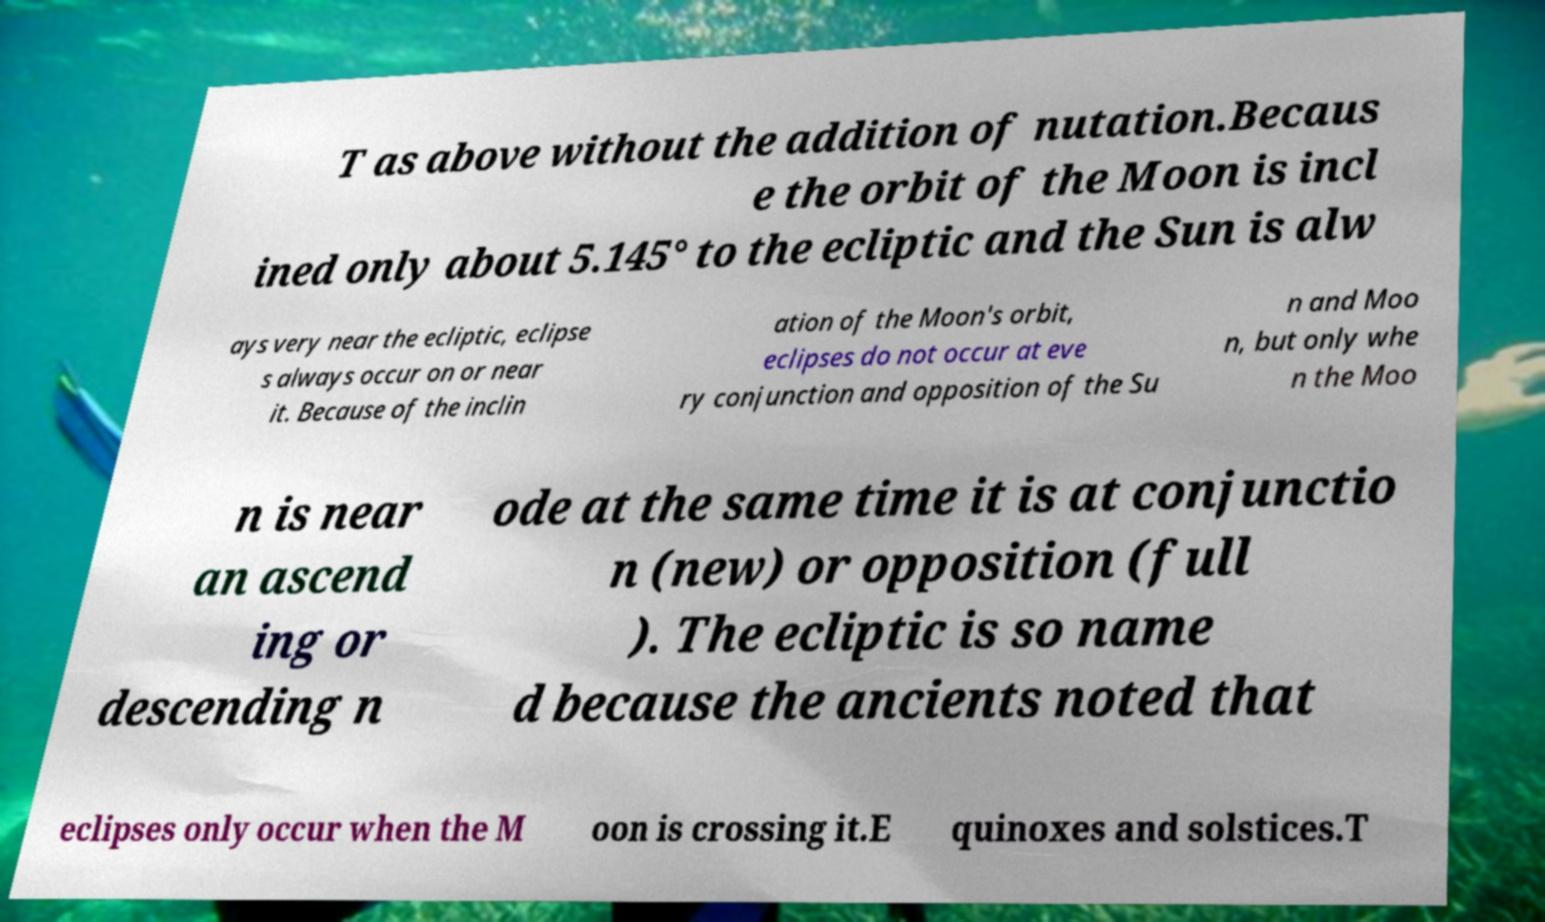Can you read and provide the text displayed in the image?This photo seems to have some interesting text. Can you extract and type it out for me? T as above without the addition of nutation.Becaus e the orbit of the Moon is incl ined only about 5.145° to the ecliptic and the Sun is alw ays very near the ecliptic, eclipse s always occur on or near it. Because of the inclin ation of the Moon's orbit, eclipses do not occur at eve ry conjunction and opposition of the Su n and Moo n, but only whe n the Moo n is near an ascend ing or descending n ode at the same time it is at conjunctio n (new) or opposition (full ). The ecliptic is so name d because the ancients noted that eclipses only occur when the M oon is crossing it.E quinoxes and solstices.T 